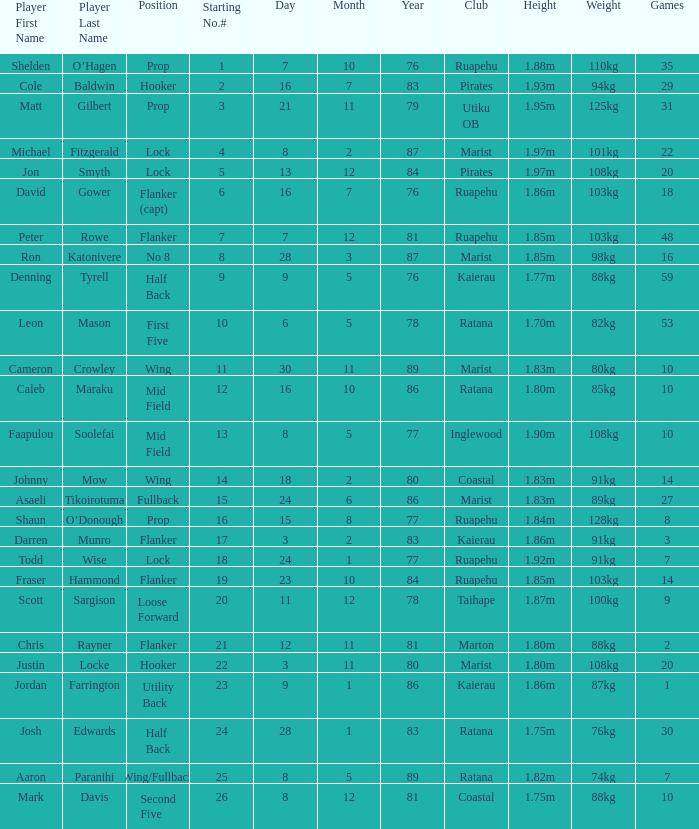What position does the player Todd Wise play in? Lock. 